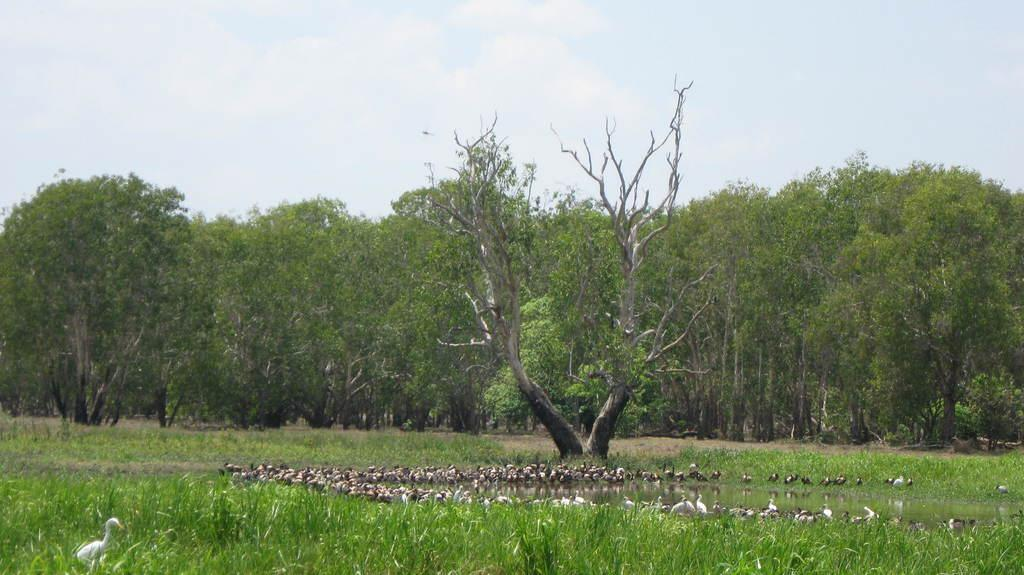What type of vegetation can be seen in the image? There are trees in the image. What structures are located beside the lake in the image? There are cranes beside the lake in the image. What type of vegetation is at the bottom of the image? There are plants at the bottom of the image. What is visible at the top of the image? The sky is visible at the top of the image. Can you tell me what your sister is doing in the image? There is no reference to a sister or any person in the image, so it is not possible to answer that question. 